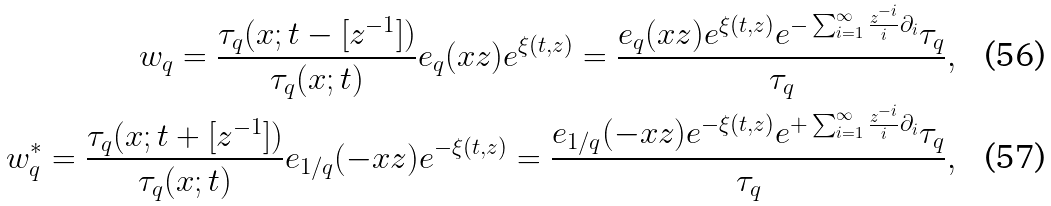<formula> <loc_0><loc_0><loc_500><loc_500>w _ { q } = \frac { \tau _ { q } ( x ; t - [ z ^ { - 1 } ] ) } { \tau _ { q } ( x ; t ) } e _ { q } ( x z ) e ^ { \xi ( t , z ) } = \frac { e _ { q } ( x z ) e ^ { \xi ( t , z ) } e ^ { - \sum _ { i = 1 } ^ { \infty } \frac { z ^ { - i } } { i } \partial _ { i } } \tau _ { q } } { \tau _ { q } } , \\ w _ { q } ^ { * } = \frac { \tau _ { q } ( x ; t + [ z ^ { - 1 } ] ) } { \tau _ { q } ( x ; t ) } e _ { 1 / q } ( - x z ) e ^ { - \xi ( t , z ) } = \frac { e _ { 1 / q } ( - x z ) e ^ { - \xi ( t , z ) } e ^ { + \sum _ { i = 1 } ^ { \infty } \frac { z ^ { - i } } { i } \partial _ { i } } \tau _ { q } } { \tau _ { q } } ,</formula> 